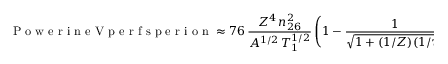Convert formula to latex. <formula><loc_0><loc_0><loc_500><loc_500>P o w e r i n e V p e r f s p e r i o n \approx 7 6 \, \frac { Z ^ { 4 } \, n _ { 2 6 } ^ { 2 } } { A ^ { 1 / 2 } \, T _ { 1 } ^ { 1 / 2 } } \left ( 1 - \frac { 1 } { \sqrt { 1 + ( 1 / Z ) ( 1 / \tau ) } } \right ) .</formula> 